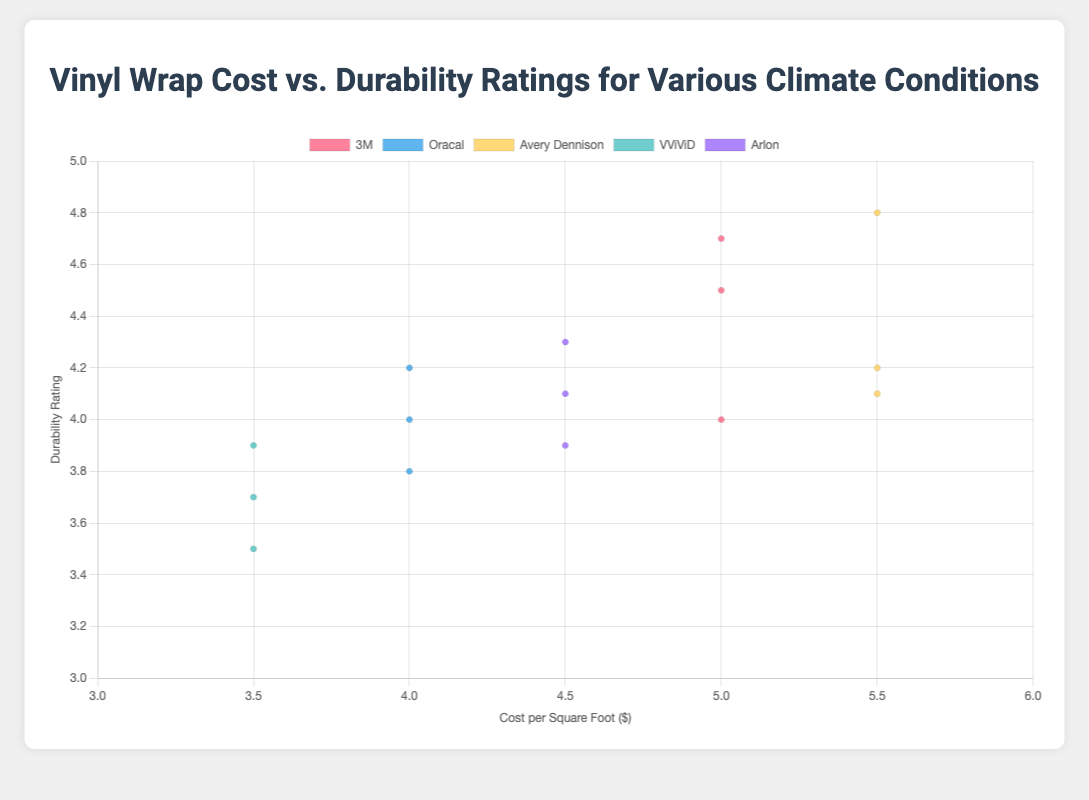What is the title of the chart? The title is located at the top center of the chart and written in larger bold text. Simply reading the title gives the answer.
Answer: Vinyl Wrap Cost vs. Durability Ratings for Various Climate Conditions What is the cost per square foot range shown on the x-axis? The range for cost per square foot can be identified by observing the minimum and maximum values of the x-axis. The minimum value is 3, and the maximum value is 6.
Answer: 3 to 6 Which brand has the highest durability rating in cold climates? Look for data points labeled with "Cold" climate and identify the one with the highest durability rating on the y-axis. Avery Dennison has a rating of 4.8 in cold climates, which is the highest.
Answer: Avery Dennison Comparing 3M and VViViD, which brand is more cost-effective (lower cost per square foot) for tropical climates while maintaining at least a 4.0 durability rating? Identify the data points for 3M and VViViD in the tropical climate category and compare their costs. VViViD has a durability rating of 3.7, which is below 4.0, so it's disqualified. 3M has a durability rating above 4.0 at the cost of $5.0 per square foot.
Answer: 3M Which two brands have the closest average cost per square foot across all climates? Calculate the average cost for each brand: 3M ($5.0), Oracal ($4.0), Avery Dennison ($5.5), VViViD ($3.5), Arlon ($4.5). Compare the averages to find the closest values, which are Oracal ($4.0) and Arlon ($4.5).
Answer: Oracal and Arlon How does the cost per square foot of VViViD compare to Avery Dennison in dry climates? Check the x-axis values for both VViViD and Avery Dennison data points in the dry climate category. VViViD has a cost per square foot of $3.5, while Avery Dennison is $5.5.
Answer: VViViD is cheaper What is the overall trend of durability ratings as costs increase for all brands in dry climates? Look at the data points labeled with "Dry" and observe their positions. There is a general trend that higher costs correlate with higher durability ratings.
Answer: Higher costs tend to have higher durability ratings Which brand appears to provide the best balance of cost and durability rating across all climates? Assess the data points to find a brand with consistently high durability ratings and moderate costs. Avery Dennison offers high durability and costs consistently around $5.5, whereas 3M also provides a good balance at $5.0. Both brands are strong contenders.
Answer: Avery Dennison or 3M What is the difference in durability ratings between the highest-rated 3M and VViViD product in cold climates? Identify the highest durability ratings for 3M and VViViD in cold climates, which are 4.7 and 3.9, respectively. The difference is 4.7 - 3.9.
Answer: 0.8 Are there any brands that have identical costs across all climate conditions, and if so, which ones? Check the data to see if any brands have the same cost per square foot in tropical, dry, and cold climates. 3M, Oracal, and VViViD maintain the same cost across all conditions ($5.0, $4.0, and $3.5 respectively).
Answer: 3M, Oracal, VViViD 